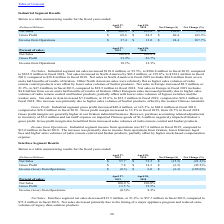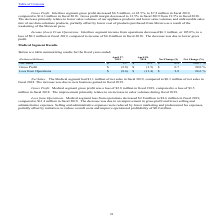According to Methode Electronics's financial document, How much was the Interface segment income from operations in fiscal 2019? Interface segment income from operations decreased $6.3 million, or 105.0%, to a loss of $0.3 million in fiscal 2019. The document states: "Income (Loss) From Operations. Interface segment income from operations decreased $6.3 million, or 105.0%, to a loss of $0.3 million in fiscal 2019, c..." Also, can you calculate: What is the average Gross Profit for Fiscal Year Ended April 28, 2018 to Fiscal Year Ended April 27, 2019? To answer this question, I need to perform calculations using the financial data. The calculation is: (7.8+14.3) / 2, which equals 11.05 (in millions). This is based on the information: "Gross Profit $ 7.8 $ 14.3 $ (6.5) (45.5)% Gross Profit $ 7.8 $ 14.3 $ (6.5) (45.5)%..." The key data points involved are: 14.3, 7.8. Also, can you calculate: What is the average Income (Loss) from Operations for Fiscal Year Ended April 28, 2018 to Fiscal Year Ended April 27, 2019? To answer this question, I need to perform calculations using the financial data. The calculation is: (0.3+6.0) / 2, which equals 3.15 (in millions). This is based on the information: "Income (Loss) from Operations $ (0.3) $ 6.0 $ (6.3) (105.0)% Income (Loss) from Operations $ (0.3) $ 6.0 $ (6.3) (105.0)%..." The key data points involved are: 0.3, 6.0. Additionally, In which period was net sales greater than 70 million? According to the financial document, 2018. The relevant text states: "2018 Net Change ($) Net Change (%)..." Also, What was the Gross Profit in 2019 and 2018? The document shows two values: $ 7.8 and $ 14.3 (in millions). From the document: "Gross Profit $ 7.8 $ 14.3 $ (6.5) (45.5)% Gross Profit $ 7.8 $ 14.3 $ (6.5) (45.5)%..." Also, What was the decrease in net sales from interface segment in 2019? According to the financial document, $15.5 million. The relevant text states: "Net Sales . Interface segment net sales decreased $15.5 million, or 21.2%, to $57.7 million in fiscal 2019, compared to..." 